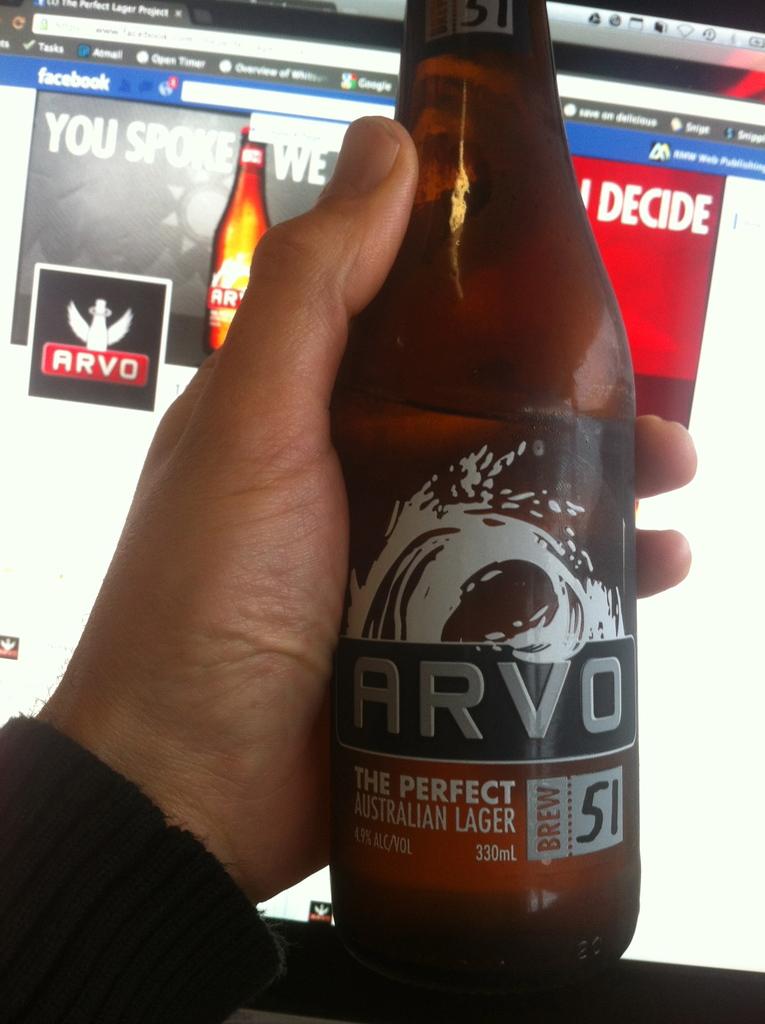What is the number next to the label brew?
Your answer should be very brief. 51. What country is this from?>?
Ensure brevity in your answer.  Australia. 